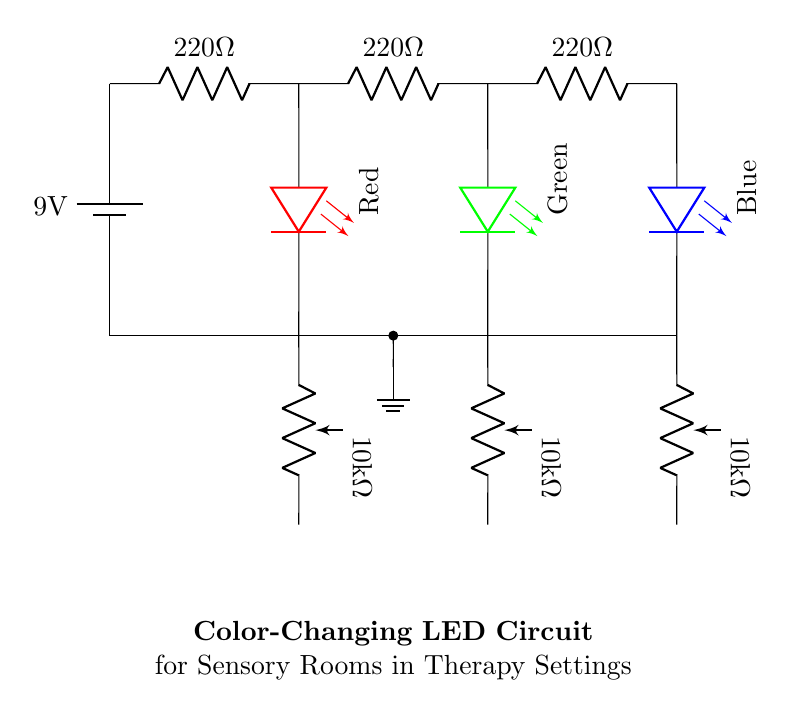What is the total voltage of the circuit? The circuit is powered by a 9-volt battery, which is indicated at the top of the circuit diagram. This voltage is the total potential provided by the battery across the circuit.
Answer: 9 volts How many resistors are in the circuit? There are three resistors connected in series in the circuit diagram, as seen on the upper part of the drawing. Each is labeled with a value of 220 ohms.
Answer: Three What is the resistance value of each potentiometer? Each potentiometer in the circuit is labeled with a resistance value of 10 kilohms. This is shown near each potentiometer in the diagram.
Answer: 10 kilohms Which colors do the LEDs represent? The circuit contains three LEDs, each representing a different color: red, green, and blue. The colors are labeled accordingly in the circuit diagram.
Answer: Red, green, blue What is the function of the potentiometers in this circuit? The potentiometers allow for adjustable resistance, which lets users modify the brightness of each LED. This is crucial for creating different lighting effects in therapy settings.
Answer: Adjustable brightness In what arrangement are the resistors connected? The resistors are connected in series, as indicated by their arrangement in one line without any branching or parallel connections in between.
Answer: Series How many LED colors can be created by this circuit configuration? This circuit incorporates red, green, and blue LEDs, and by varying their brightness through the potentiometers, it can create multiple color combinations, including white and other shades.
Answer: Multiple colors 